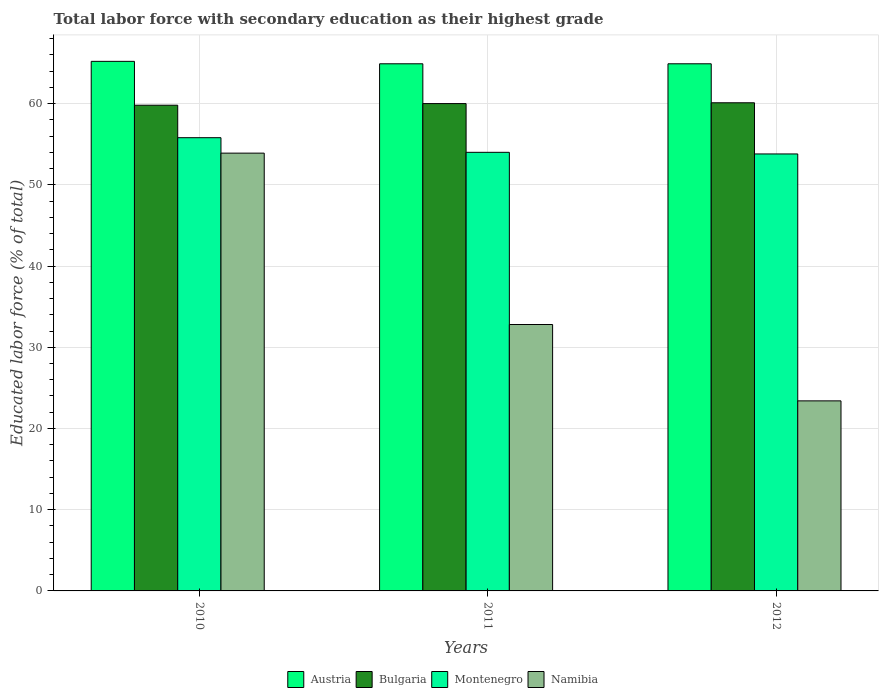How many bars are there on the 2nd tick from the right?
Keep it short and to the point. 4. What is the label of the 2nd group of bars from the left?
Your answer should be very brief. 2011. What is the percentage of total labor force with primary education in Namibia in 2012?
Give a very brief answer. 23.4. Across all years, what is the maximum percentage of total labor force with primary education in Austria?
Offer a very short reply. 65.2. Across all years, what is the minimum percentage of total labor force with primary education in Bulgaria?
Give a very brief answer. 59.8. In which year was the percentage of total labor force with primary education in Montenegro maximum?
Give a very brief answer. 2010. What is the total percentage of total labor force with primary education in Namibia in the graph?
Keep it short and to the point. 110.1. What is the difference between the percentage of total labor force with primary education in Namibia in 2010 and that in 2011?
Give a very brief answer. 21.1. What is the difference between the percentage of total labor force with primary education in Austria in 2011 and the percentage of total labor force with primary education in Bulgaria in 2012?
Provide a short and direct response. 4.8. What is the average percentage of total labor force with primary education in Namibia per year?
Keep it short and to the point. 36.7. In the year 2011, what is the difference between the percentage of total labor force with primary education in Montenegro and percentage of total labor force with primary education in Austria?
Your answer should be very brief. -10.9. In how many years, is the percentage of total labor force with primary education in Bulgaria greater than 48 %?
Your answer should be very brief. 3. What is the ratio of the percentage of total labor force with primary education in Namibia in 2010 to that in 2012?
Make the answer very short. 2.3. Is the difference between the percentage of total labor force with primary education in Montenegro in 2010 and 2012 greater than the difference between the percentage of total labor force with primary education in Austria in 2010 and 2012?
Ensure brevity in your answer.  Yes. What is the difference between the highest and the second highest percentage of total labor force with primary education in Bulgaria?
Make the answer very short. 0.1. What is the difference between the highest and the lowest percentage of total labor force with primary education in Austria?
Make the answer very short. 0.3. What does the 4th bar from the left in 2011 represents?
Provide a succinct answer. Namibia. What does the 3rd bar from the right in 2011 represents?
Your answer should be compact. Bulgaria. Is it the case that in every year, the sum of the percentage of total labor force with primary education in Bulgaria and percentage of total labor force with primary education in Namibia is greater than the percentage of total labor force with primary education in Austria?
Keep it short and to the point. Yes. Are all the bars in the graph horizontal?
Offer a terse response. No. How many years are there in the graph?
Provide a short and direct response. 3. Are the values on the major ticks of Y-axis written in scientific E-notation?
Your response must be concise. No. How many legend labels are there?
Make the answer very short. 4. How are the legend labels stacked?
Keep it short and to the point. Horizontal. What is the title of the graph?
Give a very brief answer. Total labor force with secondary education as their highest grade. What is the label or title of the X-axis?
Provide a succinct answer. Years. What is the label or title of the Y-axis?
Provide a short and direct response. Educated labor force (% of total). What is the Educated labor force (% of total) in Austria in 2010?
Your answer should be very brief. 65.2. What is the Educated labor force (% of total) of Bulgaria in 2010?
Keep it short and to the point. 59.8. What is the Educated labor force (% of total) of Montenegro in 2010?
Provide a short and direct response. 55.8. What is the Educated labor force (% of total) in Namibia in 2010?
Ensure brevity in your answer.  53.9. What is the Educated labor force (% of total) in Austria in 2011?
Ensure brevity in your answer.  64.9. What is the Educated labor force (% of total) in Namibia in 2011?
Your answer should be very brief. 32.8. What is the Educated labor force (% of total) in Austria in 2012?
Give a very brief answer. 64.9. What is the Educated labor force (% of total) of Bulgaria in 2012?
Your answer should be compact. 60.1. What is the Educated labor force (% of total) in Montenegro in 2012?
Your answer should be very brief. 53.8. What is the Educated labor force (% of total) in Namibia in 2012?
Provide a succinct answer. 23.4. Across all years, what is the maximum Educated labor force (% of total) of Austria?
Your answer should be compact. 65.2. Across all years, what is the maximum Educated labor force (% of total) of Bulgaria?
Provide a short and direct response. 60.1. Across all years, what is the maximum Educated labor force (% of total) in Montenegro?
Ensure brevity in your answer.  55.8. Across all years, what is the maximum Educated labor force (% of total) in Namibia?
Offer a terse response. 53.9. Across all years, what is the minimum Educated labor force (% of total) of Austria?
Make the answer very short. 64.9. Across all years, what is the minimum Educated labor force (% of total) in Bulgaria?
Provide a succinct answer. 59.8. Across all years, what is the minimum Educated labor force (% of total) in Montenegro?
Offer a very short reply. 53.8. Across all years, what is the minimum Educated labor force (% of total) in Namibia?
Provide a short and direct response. 23.4. What is the total Educated labor force (% of total) of Austria in the graph?
Provide a succinct answer. 195. What is the total Educated labor force (% of total) of Bulgaria in the graph?
Keep it short and to the point. 179.9. What is the total Educated labor force (% of total) of Montenegro in the graph?
Offer a very short reply. 163.6. What is the total Educated labor force (% of total) in Namibia in the graph?
Offer a very short reply. 110.1. What is the difference between the Educated labor force (% of total) in Namibia in 2010 and that in 2011?
Provide a succinct answer. 21.1. What is the difference between the Educated labor force (% of total) in Namibia in 2010 and that in 2012?
Offer a terse response. 30.5. What is the difference between the Educated labor force (% of total) in Bulgaria in 2011 and that in 2012?
Give a very brief answer. -0.1. What is the difference between the Educated labor force (% of total) in Montenegro in 2011 and that in 2012?
Make the answer very short. 0.2. What is the difference between the Educated labor force (% of total) in Austria in 2010 and the Educated labor force (% of total) in Bulgaria in 2011?
Ensure brevity in your answer.  5.2. What is the difference between the Educated labor force (% of total) of Austria in 2010 and the Educated labor force (% of total) of Montenegro in 2011?
Your response must be concise. 11.2. What is the difference between the Educated labor force (% of total) in Austria in 2010 and the Educated labor force (% of total) in Namibia in 2011?
Offer a terse response. 32.4. What is the difference between the Educated labor force (% of total) in Montenegro in 2010 and the Educated labor force (% of total) in Namibia in 2011?
Provide a short and direct response. 23. What is the difference between the Educated labor force (% of total) of Austria in 2010 and the Educated labor force (% of total) of Bulgaria in 2012?
Offer a terse response. 5.1. What is the difference between the Educated labor force (% of total) of Austria in 2010 and the Educated labor force (% of total) of Montenegro in 2012?
Your answer should be very brief. 11.4. What is the difference between the Educated labor force (% of total) in Austria in 2010 and the Educated labor force (% of total) in Namibia in 2012?
Make the answer very short. 41.8. What is the difference between the Educated labor force (% of total) of Bulgaria in 2010 and the Educated labor force (% of total) of Montenegro in 2012?
Ensure brevity in your answer.  6. What is the difference between the Educated labor force (% of total) in Bulgaria in 2010 and the Educated labor force (% of total) in Namibia in 2012?
Provide a short and direct response. 36.4. What is the difference between the Educated labor force (% of total) in Montenegro in 2010 and the Educated labor force (% of total) in Namibia in 2012?
Your answer should be compact. 32.4. What is the difference between the Educated labor force (% of total) of Austria in 2011 and the Educated labor force (% of total) of Bulgaria in 2012?
Your answer should be very brief. 4.8. What is the difference between the Educated labor force (% of total) in Austria in 2011 and the Educated labor force (% of total) in Namibia in 2012?
Your answer should be compact. 41.5. What is the difference between the Educated labor force (% of total) in Bulgaria in 2011 and the Educated labor force (% of total) in Montenegro in 2012?
Give a very brief answer. 6.2. What is the difference between the Educated labor force (% of total) in Bulgaria in 2011 and the Educated labor force (% of total) in Namibia in 2012?
Keep it short and to the point. 36.6. What is the difference between the Educated labor force (% of total) of Montenegro in 2011 and the Educated labor force (% of total) of Namibia in 2012?
Provide a succinct answer. 30.6. What is the average Educated labor force (% of total) of Bulgaria per year?
Make the answer very short. 59.97. What is the average Educated labor force (% of total) in Montenegro per year?
Offer a very short reply. 54.53. What is the average Educated labor force (% of total) in Namibia per year?
Your answer should be very brief. 36.7. In the year 2010, what is the difference between the Educated labor force (% of total) in Austria and Educated labor force (% of total) in Namibia?
Your answer should be compact. 11.3. In the year 2011, what is the difference between the Educated labor force (% of total) of Austria and Educated labor force (% of total) of Bulgaria?
Provide a short and direct response. 4.9. In the year 2011, what is the difference between the Educated labor force (% of total) of Austria and Educated labor force (% of total) of Namibia?
Keep it short and to the point. 32.1. In the year 2011, what is the difference between the Educated labor force (% of total) of Bulgaria and Educated labor force (% of total) of Namibia?
Ensure brevity in your answer.  27.2. In the year 2011, what is the difference between the Educated labor force (% of total) in Montenegro and Educated labor force (% of total) in Namibia?
Ensure brevity in your answer.  21.2. In the year 2012, what is the difference between the Educated labor force (% of total) of Austria and Educated labor force (% of total) of Bulgaria?
Your answer should be very brief. 4.8. In the year 2012, what is the difference between the Educated labor force (% of total) of Austria and Educated labor force (% of total) of Namibia?
Make the answer very short. 41.5. In the year 2012, what is the difference between the Educated labor force (% of total) of Bulgaria and Educated labor force (% of total) of Montenegro?
Provide a succinct answer. 6.3. In the year 2012, what is the difference between the Educated labor force (% of total) in Bulgaria and Educated labor force (% of total) in Namibia?
Your answer should be compact. 36.7. In the year 2012, what is the difference between the Educated labor force (% of total) in Montenegro and Educated labor force (% of total) in Namibia?
Ensure brevity in your answer.  30.4. What is the ratio of the Educated labor force (% of total) in Montenegro in 2010 to that in 2011?
Provide a short and direct response. 1.03. What is the ratio of the Educated labor force (% of total) in Namibia in 2010 to that in 2011?
Your answer should be compact. 1.64. What is the ratio of the Educated labor force (% of total) of Austria in 2010 to that in 2012?
Offer a very short reply. 1. What is the ratio of the Educated labor force (% of total) of Montenegro in 2010 to that in 2012?
Provide a short and direct response. 1.04. What is the ratio of the Educated labor force (% of total) of Namibia in 2010 to that in 2012?
Make the answer very short. 2.3. What is the ratio of the Educated labor force (% of total) in Bulgaria in 2011 to that in 2012?
Give a very brief answer. 1. What is the ratio of the Educated labor force (% of total) in Namibia in 2011 to that in 2012?
Your answer should be very brief. 1.4. What is the difference between the highest and the second highest Educated labor force (% of total) in Austria?
Provide a short and direct response. 0.3. What is the difference between the highest and the second highest Educated labor force (% of total) in Namibia?
Give a very brief answer. 21.1. What is the difference between the highest and the lowest Educated labor force (% of total) in Bulgaria?
Your response must be concise. 0.3. What is the difference between the highest and the lowest Educated labor force (% of total) in Namibia?
Provide a succinct answer. 30.5. 